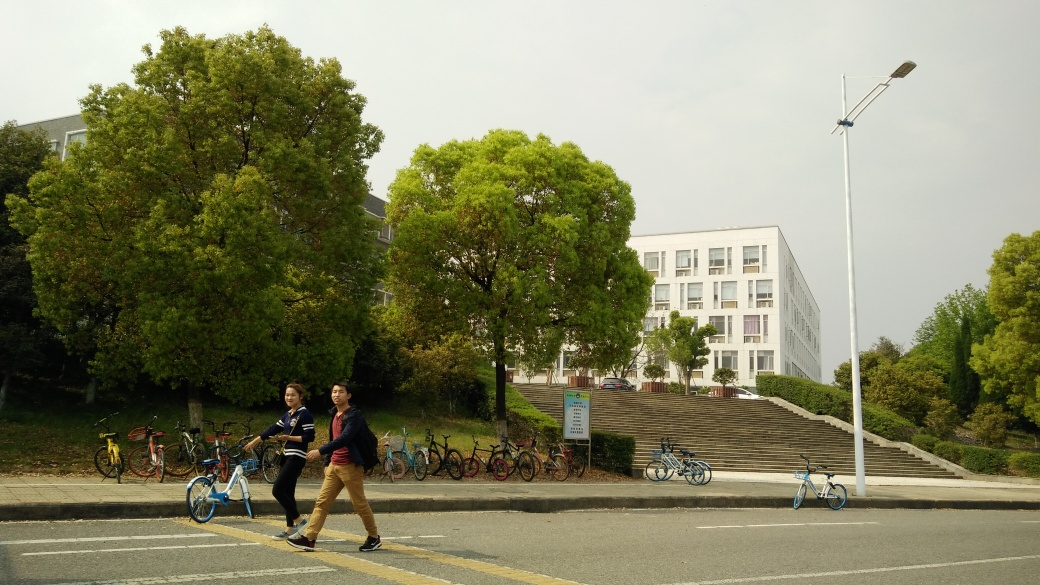Can you describe the activities happening in the image? Certainly. In the image, we see two individuals walking across the street, which suggests pedestrian movement. In the backdrop, there's a lineup of parked bicycles, indicating common use of bicycles in this area, perhaps a campus or a public space with a focus on sustainable transportation. 